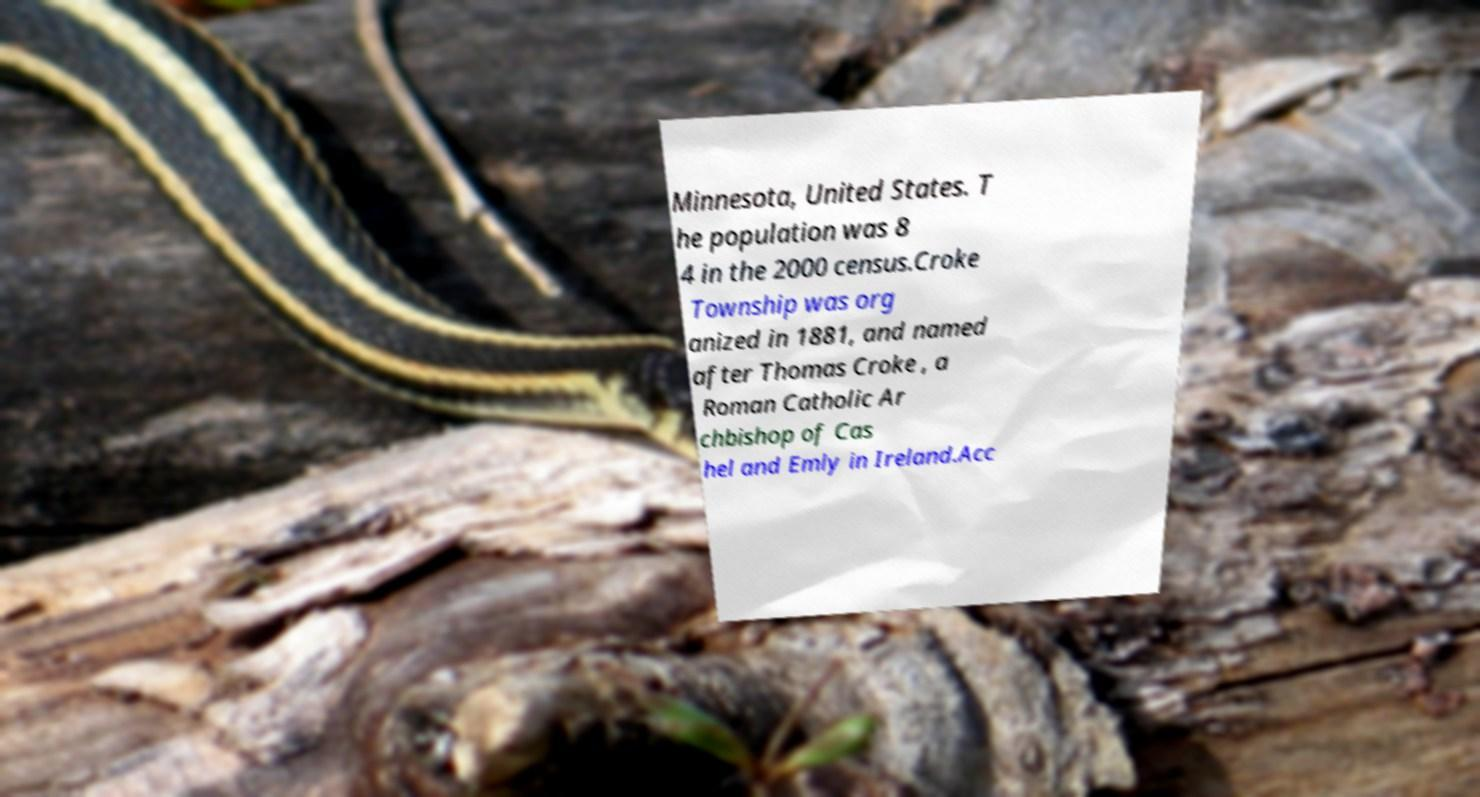Could you extract and type out the text from this image? Minnesota, United States. T he population was 8 4 in the 2000 census.Croke Township was org anized in 1881, and named after Thomas Croke , a Roman Catholic Ar chbishop of Cas hel and Emly in Ireland.Acc 